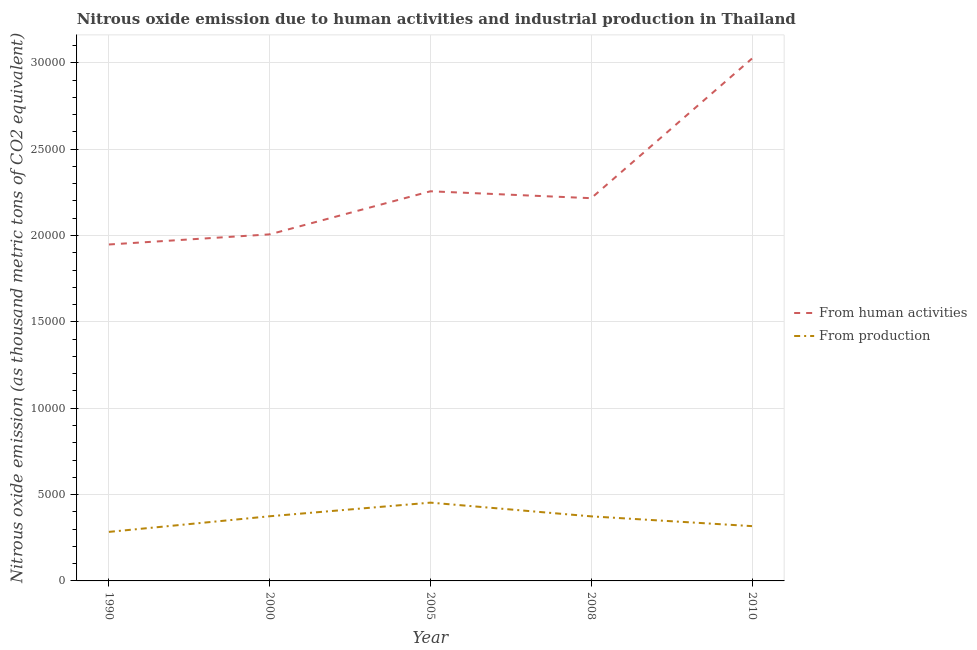Does the line corresponding to amount of emissions generated from industries intersect with the line corresponding to amount of emissions from human activities?
Your response must be concise. No. Is the number of lines equal to the number of legend labels?
Your answer should be compact. Yes. What is the amount of emissions from human activities in 2010?
Give a very brief answer. 3.02e+04. Across all years, what is the maximum amount of emissions generated from industries?
Offer a terse response. 4532.4. Across all years, what is the minimum amount of emissions from human activities?
Make the answer very short. 1.95e+04. What is the total amount of emissions generated from industries in the graph?
Your answer should be very brief. 1.80e+04. What is the difference between the amount of emissions generated from industries in 1990 and that in 2008?
Offer a very short reply. -899. What is the difference between the amount of emissions generated from industries in 2005 and the amount of emissions from human activities in 2000?
Your answer should be very brief. -1.55e+04. What is the average amount of emissions from human activities per year?
Your answer should be compact. 2.29e+04. In the year 2008, what is the difference between the amount of emissions generated from industries and amount of emissions from human activities?
Offer a very short reply. -1.84e+04. In how many years, is the amount of emissions from human activities greater than 6000 thousand metric tons?
Give a very brief answer. 5. What is the ratio of the amount of emissions from human activities in 2005 to that in 2010?
Provide a succinct answer. 0.75. Is the amount of emissions from human activities in 1990 less than that in 2000?
Your response must be concise. Yes. What is the difference between the highest and the second highest amount of emissions generated from industries?
Offer a terse response. 788.7. What is the difference between the highest and the lowest amount of emissions generated from industries?
Your answer should be very brief. 1693.5. Are the values on the major ticks of Y-axis written in scientific E-notation?
Make the answer very short. No. Does the graph contain any zero values?
Offer a terse response. No. Does the graph contain grids?
Provide a short and direct response. Yes. How many legend labels are there?
Offer a terse response. 2. How are the legend labels stacked?
Give a very brief answer. Vertical. What is the title of the graph?
Your response must be concise. Nitrous oxide emission due to human activities and industrial production in Thailand. What is the label or title of the Y-axis?
Your response must be concise. Nitrous oxide emission (as thousand metric tons of CO2 equivalent). What is the Nitrous oxide emission (as thousand metric tons of CO2 equivalent) of From human activities in 1990?
Ensure brevity in your answer.  1.95e+04. What is the Nitrous oxide emission (as thousand metric tons of CO2 equivalent) of From production in 1990?
Your answer should be compact. 2838.9. What is the Nitrous oxide emission (as thousand metric tons of CO2 equivalent) of From human activities in 2000?
Your answer should be compact. 2.01e+04. What is the Nitrous oxide emission (as thousand metric tons of CO2 equivalent) in From production in 2000?
Keep it short and to the point. 3743.7. What is the Nitrous oxide emission (as thousand metric tons of CO2 equivalent) in From human activities in 2005?
Offer a terse response. 2.26e+04. What is the Nitrous oxide emission (as thousand metric tons of CO2 equivalent) in From production in 2005?
Your answer should be very brief. 4532.4. What is the Nitrous oxide emission (as thousand metric tons of CO2 equivalent) of From human activities in 2008?
Provide a succinct answer. 2.22e+04. What is the Nitrous oxide emission (as thousand metric tons of CO2 equivalent) of From production in 2008?
Provide a succinct answer. 3737.9. What is the Nitrous oxide emission (as thousand metric tons of CO2 equivalent) of From human activities in 2010?
Your response must be concise. 3.02e+04. What is the Nitrous oxide emission (as thousand metric tons of CO2 equivalent) of From production in 2010?
Ensure brevity in your answer.  3172.4. Across all years, what is the maximum Nitrous oxide emission (as thousand metric tons of CO2 equivalent) of From human activities?
Your answer should be compact. 3.02e+04. Across all years, what is the maximum Nitrous oxide emission (as thousand metric tons of CO2 equivalent) of From production?
Provide a succinct answer. 4532.4. Across all years, what is the minimum Nitrous oxide emission (as thousand metric tons of CO2 equivalent) in From human activities?
Give a very brief answer. 1.95e+04. Across all years, what is the minimum Nitrous oxide emission (as thousand metric tons of CO2 equivalent) in From production?
Give a very brief answer. 2838.9. What is the total Nitrous oxide emission (as thousand metric tons of CO2 equivalent) in From human activities in the graph?
Your answer should be compact. 1.15e+05. What is the total Nitrous oxide emission (as thousand metric tons of CO2 equivalent) in From production in the graph?
Give a very brief answer. 1.80e+04. What is the difference between the Nitrous oxide emission (as thousand metric tons of CO2 equivalent) in From human activities in 1990 and that in 2000?
Offer a very short reply. -586.2. What is the difference between the Nitrous oxide emission (as thousand metric tons of CO2 equivalent) of From production in 1990 and that in 2000?
Make the answer very short. -904.8. What is the difference between the Nitrous oxide emission (as thousand metric tons of CO2 equivalent) in From human activities in 1990 and that in 2005?
Offer a very short reply. -3080.2. What is the difference between the Nitrous oxide emission (as thousand metric tons of CO2 equivalent) in From production in 1990 and that in 2005?
Your answer should be compact. -1693.5. What is the difference between the Nitrous oxide emission (as thousand metric tons of CO2 equivalent) of From human activities in 1990 and that in 2008?
Ensure brevity in your answer.  -2680.3. What is the difference between the Nitrous oxide emission (as thousand metric tons of CO2 equivalent) in From production in 1990 and that in 2008?
Offer a terse response. -899. What is the difference between the Nitrous oxide emission (as thousand metric tons of CO2 equivalent) in From human activities in 1990 and that in 2010?
Make the answer very short. -1.08e+04. What is the difference between the Nitrous oxide emission (as thousand metric tons of CO2 equivalent) in From production in 1990 and that in 2010?
Make the answer very short. -333.5. What is the difference between the Nitrous oxide emission (as thousand metric tons of CO2 equivalent) of From human activities in 2000 and that in 2005?
Offer a very short reply. -2494. What is the difference between the Nitrous oxide emission (as thousand metric tons of CO2 equivalent) of From production in 2000 and that in 2005?
Ensure brevity in your answer.  -788.7. What is the difference between the Nitrous oxide emission (as thousand metric tons of CO2 equivalent) in From human activities in 2000 and that in 2008?
Your answer should be very brief. -2094.1. What is the difference between the Nitrous oxide emission (as thousand metric tons of CO2 equivalent) of From production in 2000 and that in 2008?
Your answer should be very brief. 5.8. What is the difference between the Nitrous oxide emission (as thousand metric tons of CO2 equivalent) in From human activities in 2000 and that in 2010?
Provide a short and direct response. -1.02e+04. What is the difference between the Nitrous oxide emission (as thousand metric tons of CO2 equivalent) of From production in 2000 and that in 2010?
Offer a terse response. 571.3. What is the difference between the Nitrous oxide emission (as thousand metric tons of CO2 equivalent) in From human activities in 2005 and that in 2008?
Offer a very short reply. 399.9. What is the difference between the Nitrous oxide emission (as thousand metric tons of CO2 equivalent) in From production in 2005 and that in 2008?
Provide a short and direct response. 794.5. What is the difference between the Nitrous oxide emission (as thousand metric tons of CO2 equivalent) in From human activities in 2005 and that in 2010?
Keep it short and to the point. -7685.5. What is the difference between the Nitrous oxide emission (as thousand metric tons of CO2 equivalent) in From production in 2005 and that in 2010?
Give a very brief answer. 1360. What is the difference between the Nitrous oxide emission (as thousand metric tons of CO2 equivalent) of From human activities in 2008 and that in 2010?
Ensure brevity in your answer.  -8085.4. What is the difference between the Nitrous oxide emission (as thousand metric tons of CO2 equivalent) of From production in 2008 and that in 2010?
Your answer should be compact. 565.5. What is the difference between the Nitrous oxide emission (as thousand metric tons of CO2 equivalent) of From human activities in 1990 and the Nitrous oxide emission (as thousand metric tons of CO2 equivalent) of From production in 2000?
Provide a succinct answer. 1.57e+04. What is the difference between the Nitrous oxide emission (as thousand metric tons of CO2 equivalent) in From human activities in 1990 and the Nitrous oxide emission (as thousand metric tons of CO2 equivalent) in From production in 2005?
Provide a short and direct response. 1.49e+04. What is the difference between the Nitrous oxide emission (as thousand metric tons of CO2 equivalent) of From human activities in 1990 and the Nitrous oxide emission (as thousand metric tons of CO2 equivalent) of From production in 2008?
Ensure brevity in your answer.  1.57e+04. What is the difference between the Nitrous oxide emission (as thousand metric tons of CO2 equivalent) of From human activities in 1990 and the Nitrous oxide emission (as thousand metric tons of CO2 equivalent) of From production in 2010?
Ensure brevity in your answer.  1.63e+04. What is the difference between the Nitrous oxide emission (as thousand metric tons of CO2 equivalent) in From human activities in 2000 and the Nitrous oxide emission (as thousand metric tons of CO2 equivalent) in From production in 2005?
Give a very brief answer. 1.55e+04. What is the difference between the Nitrous oxide emission (as thousand metric tons of CO2 equivalent) of From human activities in 2000 and the Nitrous oxide emission (as thousand metric tons of CO2 equivalent) of From production in 2008?
Your answer should be compact. 1.63e+04. What is the difference between the Nitrous oxide emission (as thousand metric tons of CO2 equivalent) of From human activities in 2000 and the Nitrous oxide emission (as thousand metric tons of CO2 equivalent) of From production in 2010?
Offer a very short reply. 1.69e+04. What is the difference between the Nitrous oxide emission (as thousand metric tons of CO2 equivalent) in From human activities in 2005 and the Nitrous oxide emission (as thousand metric tons of CO2 equivalent) in From production in 2008?
Your answer should be very brief. 1.88e+04. What is the difference between the Nitrous oxide emission (as thousand metric tons of CO2 equivalent) of From human activities in 2005 and the Nitrous oxide emission (as thousand metric tons of CO2 equivalent) of From production in 2010?
Ensure brevity in your answer.  1.94e+04. What is the difference between the Nitrous oxide emission (as thousand metric tons of CO2 equivalent) of From human activities in 2008 and the Nitrous oxide emission (as thousand metric tons of CO2 equivalent) of From production in 2010?
Offer a very short reply. 1.90e+04. What is the average Nitrous oxide emission (as thousand metric tons of CO2 equivalent) in From human activities per year?
Your response must be concise. 2.29e+04. What is the average Nitrous oxide emission (as thousand metric tons of CO2 equivalent) in From production per year?
Your answer should be compact. 3605.06. In the year 1990, what is the difference between the Nitrous oxide emission (as thousand metric tons of CO2 equivalent) in From human activities and Nitrous oxide emission (as thousand metric tons of CO2 equivalent) in From production?
Your answer should be very brief. 1.66e+04. In the year 2000, what is the difference between the Nitrous oxide emission (as thousand metric tons of CO2 equivalent) in From human activities and Nitrous oxide emission (as thousand metric tons of CO2 equivalent) in From production?
Your response must be concise. 1.63e+04. In the year 2005, what is the difference between the Nitrous oxide emission (as thousand metric tons of CO2 equivalent) in From human activities and Nitrous oxide emission (as thousand metric tons of CO2 equivalent) in From production?
Keep it short and to the point. 1.80e+04. In the year 2008, what is the difference between the Nitrous oxide emission (as thousand metric tons of CO2 equivalent) of From human activities and Nitrous oxide emission (as thousand metric tons of CO2 equivalent) of From production?
Keep it short and to the point. 1.84e+04. In the year 2010, what is the difference between the Nitrous oxide emission (as thousand metric tons of CO2 equivalent) in From human activities and Nitrous oxide emission (as thousand metric tons of CO2 equivalent) in From production?
Provide a succinct answer. 2.71e+04. What is the ratio of the Nitrous oxide emission (as thousand metric tons of CO2 equivalent) in From human activities in 1990 to that in 2000?
Provide a short and direct response. 0.97. What is the ratio of the Nitrous oxide emission (as thousand metric tons of CO2 equivalent) of From production in 1990 to that in 2000?
Your response must be concise. 0.76. What is the ratio of the Nitrous oxide emission (as thousand metric tons of CO2 equivalent) in From human activities in 1990 to that in 2005?
Keep it short and to the point. 0.86. What is the ratio of the Nitrous oxide emission (as thousand metric tons of CO2 equivalent) of From production in 1990 to that in 2005?
Provide a succinct answer. 0.63. What is the ratio of the Nitrous oxide emission (as thousand metric tons of CO2 equivalent) in From human activities in 1990 to that in 2008?
Keep it short and to the point. 0.88. What is the ratio of the Nitrous oxide emission (as thousand metric tons of CO2 equivalent) in From production in 1990 to that in 2008?
Provide a succinct answer. 0.76. What is the ratio of the Nitrous oxide emission (as thousand metric tons of CO2 equivalent) in From human activities in 1990 to that in 2010?
Your answer should be very brief. 0.64. What is the ratio of the Nitrous oxide emission (as thousand metric tons of CO2 equivalent) in From production in 1990 to that in 2010?
Make the answer very short. 0.89. What is the ratio of the Nitrous oxide emission (as thousand metric tons of CO2 equivalent) of From human activities in 2000 to that in 2005?
Your answer should be very brief. 0.89. What is the ratio of the Nitrous oxide emission (as thousand metric tons of CO2 equivalent) in From production in 2000 to that in 2005?
Offer a very short reply. 0.83. What is the ratio of the Nitrous oxide emission (as thousand metric tons of CO2 equivalent) in From human activities in 2000 to that in 2008?
Keep it short and to the point. 0.91. What is the ratio of the Nitrous oxide emission (as thousand metric tons of CO2 equivalent) of From production in 2000 to that in 2008?
Your answer should be very brief. 1. What is the ratio of the Nitrous oxide emission (as thousand metric tons of CO2 equivalent) of From human activities in 2000 to that in 2010?
Offer a very short reply. 0.66. What is the ratio of the Nitrous oxide emission (as thousand metric tons of CO2 equivalent) of From production in 2000 to that in 2010?
Your response must be concise. 1.18. What is the ratio of the Nitrous oxide emission (as thousand metric tons of CO2 equivalent) in From human activities in 2005 to that in 2008?
Your response must be concise. 1.02. What is the ratio of the Nitrous oxide emission (as thousand metric tons of CO2 equivalent) of From production in 2005 to that in 2008?
Make the answer very short. 1.21. What is the ratio of the Nitrous oxide emission (as thousand metric tons of CO2 equivalent) of From human activities in 2005 to that in 2010?
Your answer should be compact. 0.75. What is the ratio of the Nitrous oxide emission (as thousand metric tons of CO2 equivalent) in From production in 2005 to that in 2010?
Provide a short and direct response. 1.43. What is the ratio of the Nitrous oxide emission (as thousand metric tons of CO2 equivalent) of From human activities in 2008 to that in 2010?
Keep it short and to the point. 0.73. What is the ratio of the Nitrous oxide emission (as thousand metric tons of CO2 equivalent) of From production in 2008 to that in 2010?
Your answer should be compact. 1.18. What is the difference between the highest and the second highest Nitrous oxide emission (as thousand metric tons of CO2 equivalent) of From human activities?
Offer a very short reply. 7685.5. What is the difference between the highest and the second highest Nitrous oxide emission (as thousand metric tons of CO2 equivalent) in From production?
Keep it short and to the point. 788.7. What is the difference between the highest and the lowest Nitrous oxide emission (as thousand metric tons of CO2 equivalent) of From human activities?
Provide a succinct answer. 1.08e+04. What is the difference between the highest and the lowest Nitrous oxide emission (as thousand metric tons of CO2 equivalent) of From production?
Keep it short and to the point. 1693.5. 